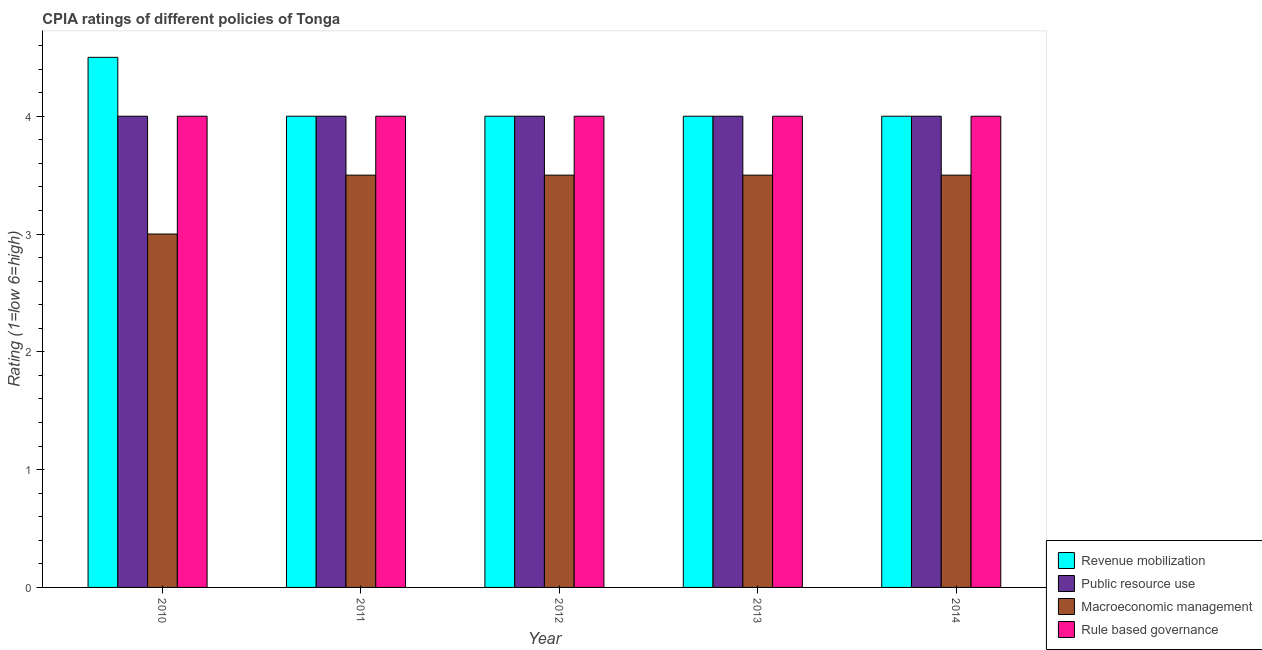How many different coloured bars are there?
Provide a succinct answer. 4. Are the number of bars on each tick of the X-axis equal?
Provide a succinct answer. Yes. How many bars are there on the 1st tick from the left?
Offer a very short reply. 4. How many bars are there on the 1st tick from the right?
Provide a succinct answer. 4. What is the label of the 1st group of bars from the left?
Offer a very short reply. 2010. What is the cpia rating of public resource use in 2012?
Your response must be concise. 4. Across all years, what is the maximum cpia rating of macroeconomic management?
Your response must be concise. 3.5. Across all years, what is the minimum cpia rating of public resource use?
Make the answer very short. 4. What is the total cpia rating of public resource use in the graph?
Keep it short and to the point. 20. What is the difference between the cpia rating of revenue mobilization in 2012 and the cpia rating of macroeconomic management in 2013?
Your response must be concise. 0. What is the average cpia rating of public resource use per year?
Keep it short and to the point. 4. In the year 2012, what is the difference between the cpia rating of revenue mobilization and cpia rating of public resource use?
Your answer should be very brief. 0. In how many years, is the cpia rating of macroeconomic management greater than 0.8?
Your answer should be compact. 5. What is the ratio of the cpia rating of public resource use in 2011 to that in 2014?
Provide a short and direct response. 1. Is the cpia rating of revenue mobilization in 2013 less than that in 2014?
Ensure brevity in your answer.  No. Is the difference between the cpia rating of public resource use in 2012 and 2013 greater than the difference between the cpia rating of rule based governance in 2012 and 2013?
Provide a short and direct response. No. What is the difference between the highest and the second highest cpia rating of rule based governance?
Ensure brevity in your answer.  0. What is the difference between the highest and the lowest cpia rating of rule based governance?
Your response must be concise. 0. In how many years, is the cpia rating of public resource use greater than the average cpia rating of public resource use taken over all years?
Make the answer very short. 0. Is the sum of the cpia rating of revenue mobilization in 2011 and 2014 greater than the maximum cpia rating of macroeconomic management across all years?
Your response must be concise. Yes. What does the 4th bar from the left in 2010 represents?
Make the answer very short. Rule based governance. What does the 4th bar from the right in 2014 represents?
Your response must be concise. Revenue mobilization. Are all the bars in the graph horizontal?
Your answer should be compact. No. What is the difference between two consecutive major ticks on the Y-axis?
Keep it short and to the point. 1. Are the values on the major ticks of Y-axis written in scientific E-notation?
Your answer should be compact. No. Does the graph contain grids?
Offer a very short reply. No. Where does the legend appear in the graph?
Give a very brief answer. Bottom right. How are the legend labels stacked?
Make the answer very short. Vertical. What is the title of the graph?
Your response must be concise. CPIA ratings of different policies of Tonga. Does "Regional development banks" appear as one of the legend labels in the graph?
Your response must be concise. No. What is the label or title of the X-axis?
Make the answer very short. Year. What is the label or title of the Y-axis?
Provide a succinct answer. Rating (1=low 6=high). What is the Rating (1=low 6=high) of Revenue mobilization in 2010?
Your answer should be compact. 4.5. What is the Rating (1=low 6=high) in Revenue mobilization in 2011?
Offer a very short reply. 4. What is the Rating (1=low 6=high) of Macroeconomic management in 2011?
Provide a short and direct response. 3.5. What is the Rating (1=low 6=high) of Rule based governance in 2011?
Give a very brief answer. 4. What is the Rating (1=low 6=high) in Revenue mobilization in 2012?
Provide a short and direct response. 4. What is the Rating (1=low 6=high) in Macroeconomic management in 2012?
Your response must be concise. 3.5. What is the Rating (1=low 6=high) of Public resource use in 2013?
Your answer should be compact. 4. What is the Rating (1=low 6=high) of Macroeconomic management in 2013?
Provide a short and direct response. 3.5. What is the Rating (1=low 6=high) in Rule based governance in 2013?
Your answer should be very brief. 4. What is the Rating (1=low 6=high) in Revenue mobilization in 2014?
Your response must be concise. 4. What is the Rating (1=low 6=high) in Public resource use in 2014?
Your answer should be compact. 4. What is the Rating (1=low 6=high) of Macroeconomic management in 2014?
Ensure brevity in your answer.  3.5. Across all years, what is the maximum Rating (1=low 6=high) of Macroeconomic management?
Your answer should be very brief. 3.5. Across all years, what is the maximum Rating (1=low 6=high) of Rule based governance?
Your answer should be very brief. 4. Across all years, what is the minimum Rating (1=low 6=high) of Revenue mobilization?
Your answer should be compact. 4. Across all years, what is the minimum Rating (1=low 6=high) of Rule based governance?
Your answer should be very brief. 4. What is the total Rating (1=low 6=high) of Public resource use in the graph?
Provide a succinct answer. 20. What is the difference between the Rating (1=low 6=high) in Public resource use in 2010 and that in 2011?
Keep it short and to the point. 0. What is the difference between the Rating (1=low 6=high) in Macroeconomic management in 2010 and that in 2011?
Your answer should be compact. -0.5. What is the difference between the Rating (1=low 6=high) in Rule based governance in 2010 and that in 2011?
Provide a short and direct response. 0. What is the difference between the Rating (1=low 6=high) of Revenue mobilization in 2010 and that in 2012?
Your response must be concise. 0.5. What is the difference between the Rating (1=low 6=high) of Macroeconomic management in 2010 and that in 2012?
Give a very brief answer. -0.5. What is the difference between the Rating (1=low 6=high) in Revenue mobilization in 2010 and that in 2013?
Offer a very short reply. 0.5. What is the difference between the Rating (1=low 6=high) of Macroeconomic management in 2010 and that in 2013?
Provide a succinct answer. -0.5. What is the difference between the Rating (1=low 6=high) of Rule based governance in 2010 and that in 2013?
Your answer should be compact. 0. What is the difference between the Rating (1=low 6=high) in Public resource use in 2010 and that in 2014?
Provide a succinct answer. 0. What is the difference between the Rating (1=low 6=high) of Macroeconomic management in 2010 and that in 2014?
Ensure brevity in your answer.  -0.5. What is the difference between the Rating (1=low 6=high) of Revenue mobilization in 2011 and that in 2012?
Your response must be concise. 0. What is the difference between the Rating (1=low 6=high) of Macroeconomic management in 2011 and that in 2012?
Give a very brief answer. 0. What is the difference between the Rating (1=low 6=high) in Rule based governance in 2011 and that in 2012?
Your answer should be compact. 0. What is the difference between the Rating (1=low 6=high) of Public resource use in 2011 and that in 2013?
Your answer should be very brief. 0. What is the difference between the Rating (1=low 6=high) of Rule based governance in 2011 and that in 2013?
Provide a short and direct response. 0. What is the difference between the Rating (1=low 6=high) of Public resource use in 2011 and that in 2014?
Offer a very short reply. 0. What is the difference between the Rating (1=low 6=high) in Macroeconomic management in 2011 and that in 2014?
Give a very brief answer. 0. What is the difference between the Rating (1=low 6=high) in Rule based governance in 2011 and that in 2014?
Provide a short and direct response. 0. What is the difference between the Rating (1=low 6=high) of Public resource use in 2012 and that in 2013?
Provide a short and direct response. 0. What is the difference between the Rating (1=low 6=high) of Rule based governance in 2012 and that in 2013?
Ensure brevity in your answer.  0. What is the difference between the Rating (1=low 6=high) of Revenue mobilization in 2012 and that in 2014?
Provide a short and direct response. 0. What is the difference between the Rating (1=low 6=high) in Rule based governance in 2012 and that in 2014?
Provide a succinct answer. 0. What is the difference between the Rating (1=low 6=high) in Public resource use in 2013 and that in 2014?
Ensure brevity in your answer.  0. What is the difference between the Rating (1=low 6=high) of Rule based governance in 2013 and that in 2014?
Make the answer very short. 0. What is the difference between the Rating (1=low 6=high) of Public resource use in 2010 and the Rating (1=low 6=high) of Macroeconomic management in 2011?
Your answer should be very brief. 0.5. What is the difference between the Rating (1=low 6=high) in Public resource use in 2010 and the Rating (1=low 6=high) in Rule based governance in 2011?
Your response must be concise. 0. What is the difference between the Rating (1=low 6=high) of Revenue mobilization in 2010 and the Rating (1=low 6=high) of Rule based governance in 2012?
Ensure brevity in your answer.  0.5. What is the difference between the Rating (1=low 6=high) of Public resource use in 2010 and the Rating (1=low 6=high) of Rule based governance in 2012?
Keep it short and to the point. 0. What is the difference between the Rating (1=low 6=high) of Macroeconomic management in 2010 and the Rating (1=low 6=high) of Rule based governance in 2012?
Offer a very short reply. -1. What is the difference between the Rating (1=low 6=high) in Revenue mobilization in 2010 and the Rating (1=low 6=high) in Public resource use in 2013?
Your answer should be compact. 0.5. What is the difference between the Rating (1=low 6=high) of Revenue mobilization in 2010 and the Rating (1=low 6=high) of Macroeconomic management in 2013?
Offer a very short reply. 1. What is the difference between the Rating (1=low 6=high) in Public resource use in 2010 and the Rating (1=low 6=high) in Macroeconomic management in 2013?
Make the answer very short. 0.5. What is the difference between the Rating (1=low 6=high) of Public resource use in 2010 and the Rating (1=low 6=high) of Macroeconomic management in 2014?
Your answer should be very brief. 0.5. What is the difference between the Rating (1=low 6=high) in Macroeconomic management in 2010 and the Rating (1=low 6=high) in Rule based governance in 2014?
Your answer should be compact. -1. What is the difference between the Rating (1=low 6=high) in Revenue mobilization in 2011 and the Rating (1=low 6=high) in Rule based governance in 2012?
Keep it short and to the point. 0. What is the difference between the Rating (1=low 6=high) in Public resource use in 2011 and the Rating (1=low 6=high) in Rule based governance in 2012?
Your response must be concise. 0. What is the difference between the Rating (1=low 6=high) in Revenue mobilization in 2011 and the Rating (1=low 6=high) in Rule based governance in 2014?
Your answer should be very brief. 0. What is the difference between the Rating (1=low 6=high) in Public resource use in 2011 and the Rating (1=low 6=high) in Macroeconomic management in 2014?
Provide a short and direct response. 0.5. What is the difference between the Rating (1=low 6=high) of Public resource use in 2011 and the Rating (1=low 6=high) of Rule based governance in 2014?
Your response must be concise. 0. What is the difference between the Rating (1=low 6=high) of Macroeconomic management in 2011 and the Rating (1=low 6=high) of Rule based governance in 2014?
Offer a very short reply. -0.5. What is the difference between the Rating (1=low 6=high) in Revenue mobilization in 2012 and the Rating (1=low 6=high) in Public resource use in 2013?
Your answer should be very brief. 0. What is the difference between the Rating (1=low 6=high) in Public resource use in 2012 and the Rating (1=low 6=high) in Macroeconomic management in 2013?
Offer a terse response. 0.5. What is the difference between the Rating (1=low 6=high) in Public resource use in 2012 and the Rating (1=low 6=high) in Rule based governance in 2013?
Ensure brevity in your answer.  0. What is the difference between the Rating (1=low 6=high) in Revenue mobilization in 2012 and the Rating (1=low 6=high) in Macroeconomic management in 2014?
Keep it short and to the point. 0.5. What is the difference between the Rating (1=low 6=high) in Revenue mobilization in 2012 and the Rating (1=low 6=high) in Rule based governance in 2014?
Offer a very short reply. 0. What is the difference between the Rating (1=low 6=high) in Public resource use in 2012 and the Rating (1=low 6=high) in Rule based governance in 2014?
Give a very brief answer. 0. What is the difference between the Rating (1=low 6=high) of Revenue mobilization in 2013 and the Rating (1=low 6=high) of Rule based governance in 2014?
Make the answer very short. 0. What is the difference between the Rating (1=low 6=high) in Macroeconomic management in 2013 and the Rating (1=low 6=high) in Rule based governance in 2014?
Offer a very short reply. -0.5. What is the average Rating (1=low 6=high) in Revenue mobilization per year?
Your response must be concise. 4.1. In the year 2010, what is the difference between the Rating (1=low 6=high) in Revenue mobilization and Rating (1=low 6=high) in Macroeconomic management?
Provide a short and direct response. 1.5. In the year 2010, what is the difference between the Rating (1=low 6=high) in Revenue mobilization and Rating (1=low 6=high) in Rule based governance?
Provide a succinct answer. 0.5. In the year 2010, what is the difference between the Rating (1=low 6=high) in Public resource use and Rating (1=low 6=high) in Rule based governance?
Your answer should be compact. 0. In the year 2011, what is the difference between the Rating (1=low 6=high) of Revenue mobilization and Rating (1=low 6=high) of Rule based governance?
Provide a short and direct response. 0. In the year 2011, what is the difference between the Rating (1=low 6=high) of Public resource use and Rating (1=low 6=high) of Macroeconomic management?
Your answer should be compact. 0.5. In the year 2011, what is the difference between the Rating (1=low 6=high) of Public resource use and Rating (1=low 6=high) of Rule based governance?
Ensure brevity in your answer.  0. In the year 2012, what is the difference between the Rating (1=low 6=high) of Revenue mobilization and Rating (1=low 6=high) of Macroeconomic management?
Give a very brief answer. 0.5. In the year 2012, what is the difference between the Rating (1=low 6=high) in Public resource use and Rating (1=low 6=high) in Macroeconomic management?
Offer a terse response. 0.5. In the year 2012, what is the difference between the Rating (1=low 6=high) of Public resource use and Rating (1=low 6=high) of Rule based governance?
Your answer should be very brief. 0. In the year 2013, what is the difference between the Rating (1=low 6=high) of Revenue mobilization and Rating (1=low 6=high) of Macroeconomic management?
Ensure brevity in your answer.  0.5. In the year 2013, what is the difference between the Rating (1=low 6=high) of Macroeconomic management and Rating (1=low 6=high) of Rule based governance?
Offer a very short reply. -0.5. In the year 2014, what is the difference between the Rating (1=low 6=high) in Macroeconomic management and Rating (1=low 6=high) in Rule based governance?
Give a very brief answer. -0.5. What is the ratio of the Rating (1=low 6=high) of Public resource use in 2010 to that in 2011?
Provide a short and direct response. 1. What is the ratio of the Rating (1=low 6=high) in Macroeconomic management in 2010 to that in 2011?
Your answer should be compact. 0.86. What is the ratio of the Rating (1=low 6=high) of Rule based governance in 2010 to that in 2011?
Ensure brevity in your answer.  1. What is the ratio of the Rating (1=low 6=high) of Revenue mobilization in 2010 to that in 2012?
Your answer should be compact. 1.12. What is the ratio of the Rating (1=low 6=high) in Public resource use in 2010 to that in 2012?
Your answer should be very brief. 1. What is the ratio of the Rating (1=low 6=high) of Rule based governance in 2010 to that in 2012?
Offer a terse response. 1. What is the ratio of the Rating (1=low 6=high) of Public resource use in 2010 to that in 2013?
Offer a very short reply. 1. What is the ratio of the Rating (1=low 6=high) of Macroeconomic management in 2010 to that in 2013?
Offer a terse response. 0.86. What is the ratio of the Rating (1=low 6=high) in Rule based governance in 2010 to that in 2013?
Provide a short and direct response. 1. What is the ratio of the Rating (1=low 6=high) in Revenue mobilization in 2010 to that in 2014?
Your answer should be very brief. 1.12. What is the ratio of the Rating (1=low 6=high) of Macroeconomic management in 2010 to that in 2014?
Give a very brief answer. 0.86. What is the ratio of the Rating (1=low 6=high) in Rule based governance in 2010 to that in 2014?
Give a very brief answer. 1. What is the ratio of the Rating (1=low 6=high) of Public resource use in 2011 to that in 2012?
Make the answer very short. 1. What is the ratio of the Rating (1=low 6=high) of Macroeconomic management in 2011 to that in 2012?
Your response must be concise. 1. What is the ratio of the Rating (1=low 6=high) in Macroeconomic management in 2011 to that in 2013?
Your answer should be very brief. 1. What is the ratio of the Rating (1=low 6=high) of Revenue mobilization in 2011 to that in 2014?
Keep it short and to the point. 1. What is the ratio of the Rating (1=low 6=high) of Public resource use in 2011 to that in 2014?
Give a very brief answer. 1. What is the ratio of the Rating (1=low 6=high) of Macroeconomic management in 2011 to that in 2014?
Keep it short and to the point. 1. What is the ratio of the Rating (1=low 6=high) in Revenue mobilization in 2012 to that in 2013?
Make the answer very short. 1. What is the ratio of the Rating (1=low 6=high) in Public resource use in 2012 to that in 2013?
Your answer should be very brief. 1. What is the ratio of the Rating (1=low 6=high) in Macroeconomic management in 2012 to that in 2013?
Your answer should be compact. 1. What is the ratio of the Rating (1=low 6=high) in Rule based governance in 2012 to that in 2013?
Your response must be concise. 1. What is the ratio of the Rating (1=low 6=high) of Revenue mobilization in 2012 to that in 2014?
Make the answer very short. 1. What is the ratio of the Rating (1=low 6=high) of Public resource use in 2012 to that in 2014?
Your answer should be very brief. 1. What is the ratio of the Rating (1=low 6=high) in Macroeconomic management in 2012 to that in 2014?
Keep it short and to the point. 1. What is the ratio of the Rating (1=low 6=high) in Revenue mobilization in 2013 to that in 2014?
Give a very brief answer. 1. What is the ratio of the Rating (1=low 6=high) of Public resource use in 2013 to that in 2014?
Your answer should be compact. 1. What is the ratio of the Rating (1=low 6=high) in Rule based governance in 2013 to that in 2014?
Your response must be concise. 1. What is the difference between the highest and the lowest Rating (1=low 6=high) of Public resource use?
Ensure brevity in your answer.  0. What is the difference between the highest and the lowest Rating (1=low 6=high) in Rule based governance?
Offer a terse response. 0. 